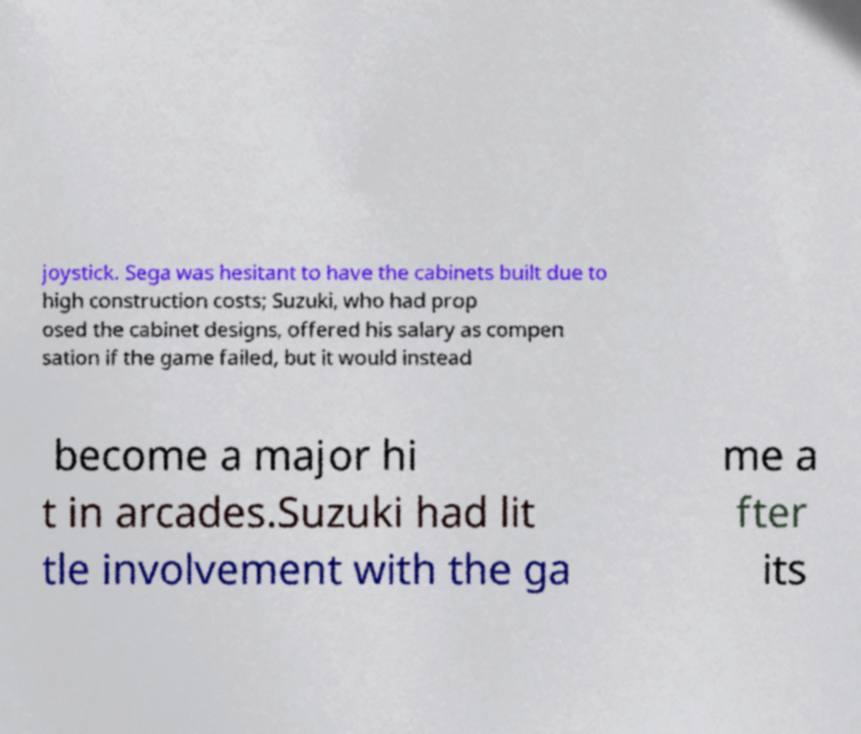For documentation purposes, I need the text within this image transcribed. Could you provide that? joystick. Sega was hesitant to have the cabinets built due to high construction costs; Suzuki, who had prop osed the cabinet designs, offered his salary as compen sation if the game failed, but it would instead become a major hi t in arcades.Suzuki had lit tle involvement with the ga me a fter its 